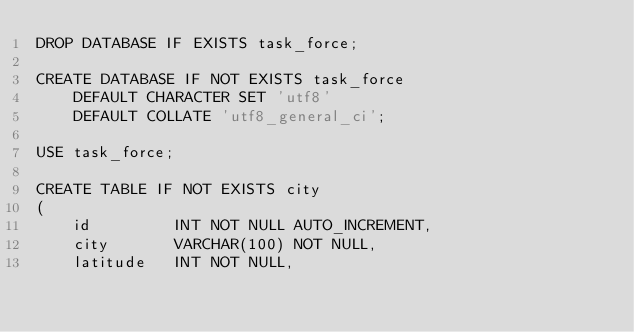<code> <loc_0><loc_0><loc_500><loc_500><_SQL_>DROP DATABASE IF EXISTS task_force;

CREATE DATABASE IF NOT EXISTS task_force
    DEFAULT CHARACTER SET 'utf8'
    DEFAULT COLLATE 'utf8_general_ci';

USE task_force;

CREATE TABLE IF NOT EXISTS city
(
    id         INT NOT NULL AUTO_INCREMENT,
    city       VARCHAR(100) NOT NULL,
    latitude   INT NOT NULL,</code> 